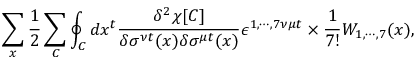Convert formula to latex. <formula><loc_0><loc_0><loc_500><loc_500>\sum _ { x } \frac { 1 } { 2 } \sum _ { C } \oint _ { C } d x ^ { t } \frac { \delta ^ { 2 } \chi [ C ] } { \delta \sigma ^ { \nu t } ( x ) \delta \sigma ^ { \mu t } ( x ) } \epsilon ^ { 1 , \cdots , 7 \nu \mu t } \times \frac { 1 } { 7 ! } W _ { 1 , \cdots , 7 } ( x ) ,</formula> 